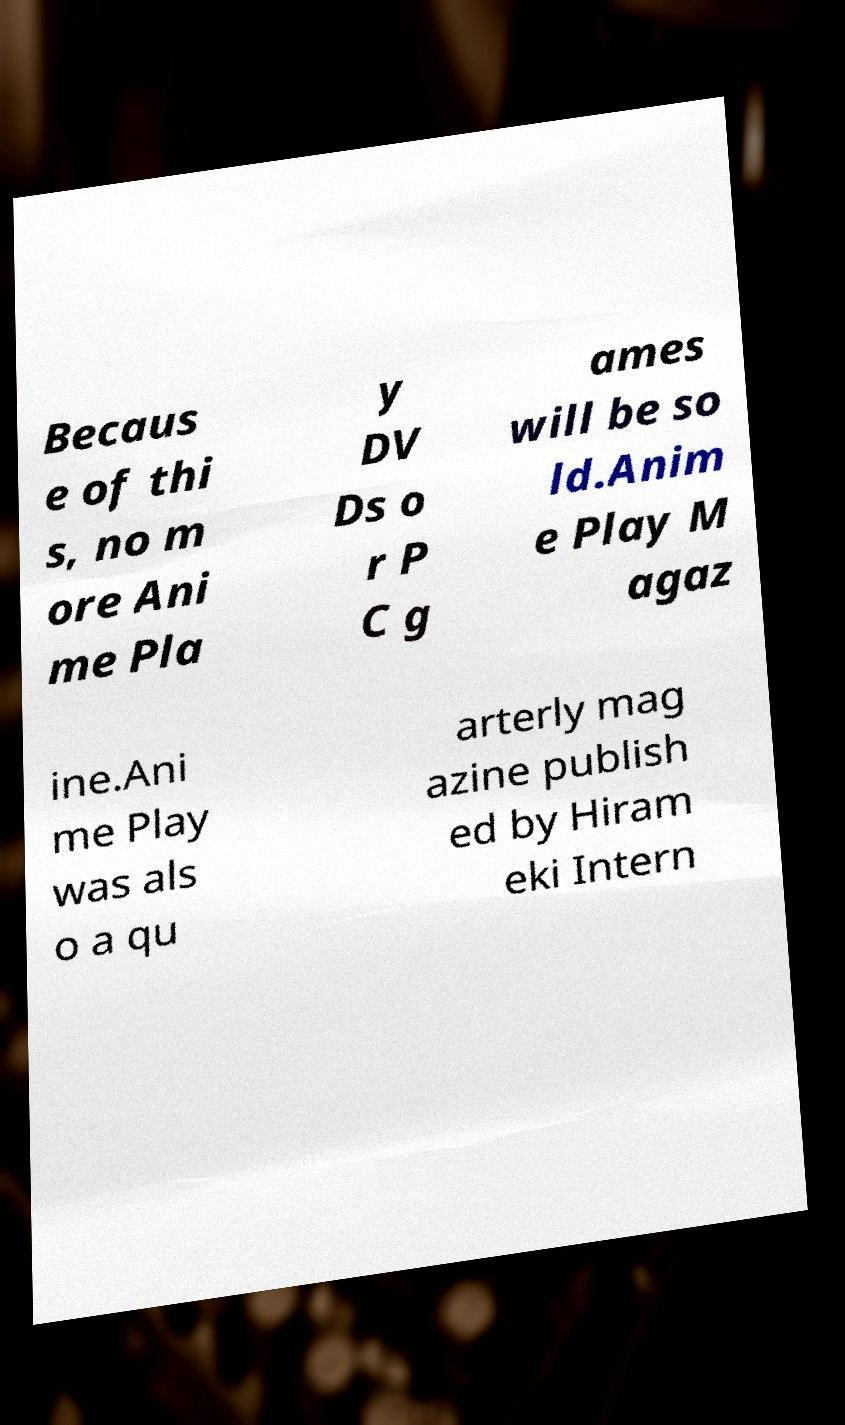Can you accurately transcribe the text from the provided image for me? Becaus e of thi s, no m ore Ani me Pla y DV Ds o r P C g ames will be so ld.Anim e Play M agaz ine.Ani me Play was als o a qu arterly mag azine publish ed by Hiram eki Intern 